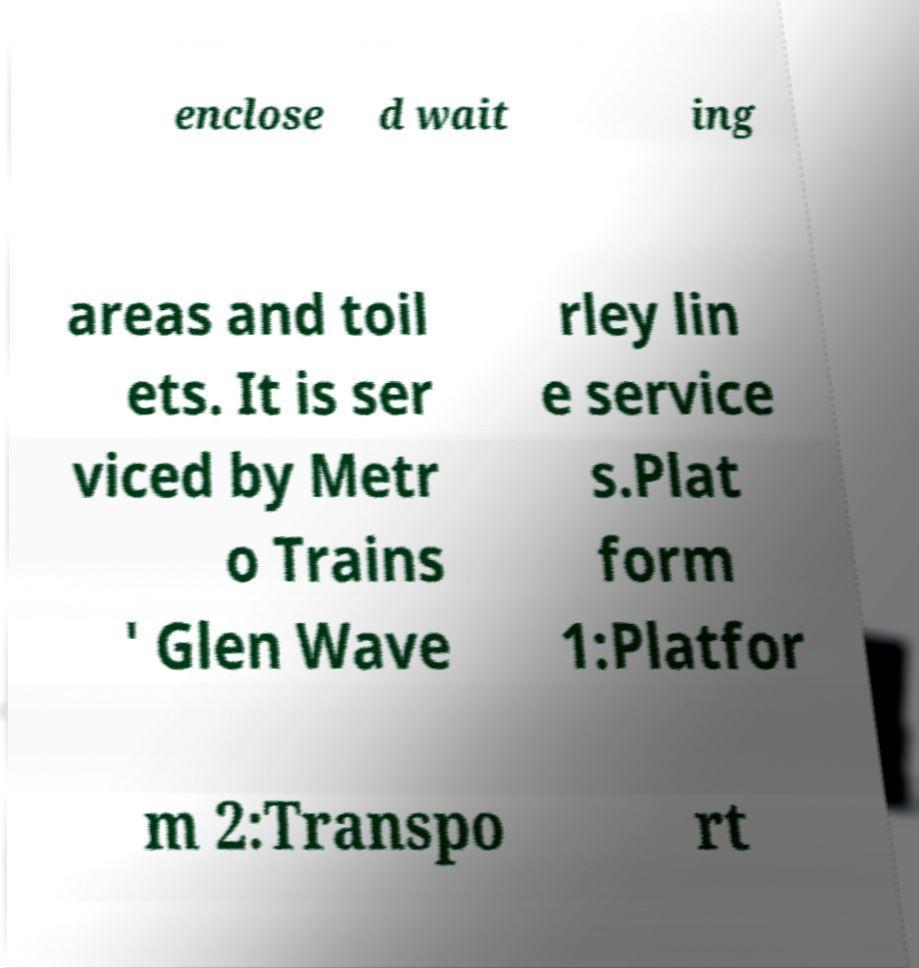I need the written content from this picture converted into text. Can you do that? enclose d wait ing areas and toil ets. It is ser viced by Metr o Trains ' Glen Wave rley lin e service s.Plat form 1:Platfor m 2:Transpo rt 